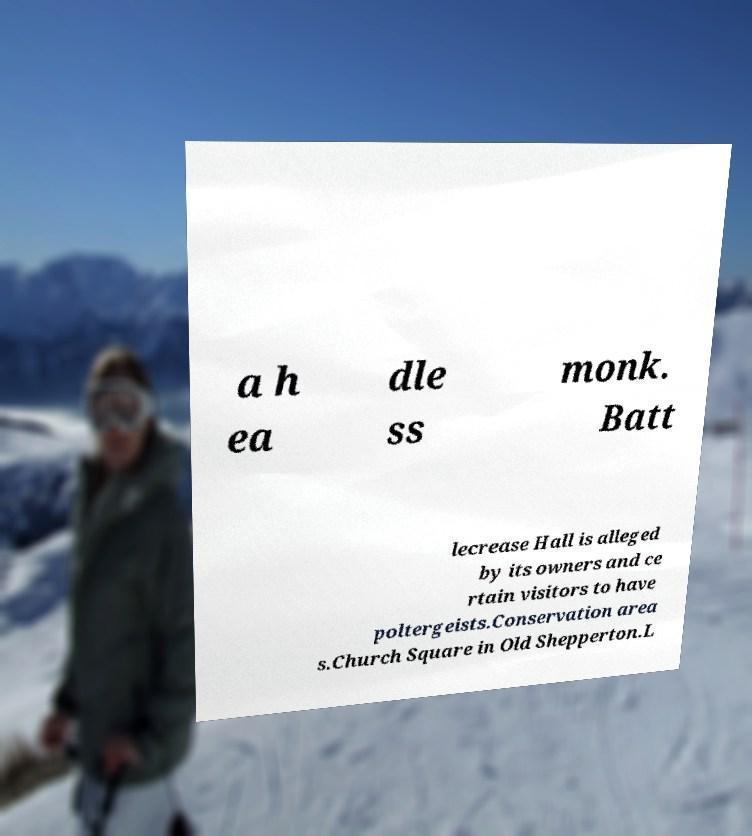There's text embedded in this image that I need extracted. Can you transcribe it verbatim? a h ea dle ss monk. Batt lecrease Hall is alleged by its owners and ce rtain visitors to have poltergeists.Conservation area s.Church Square in Old Shepperton.L 